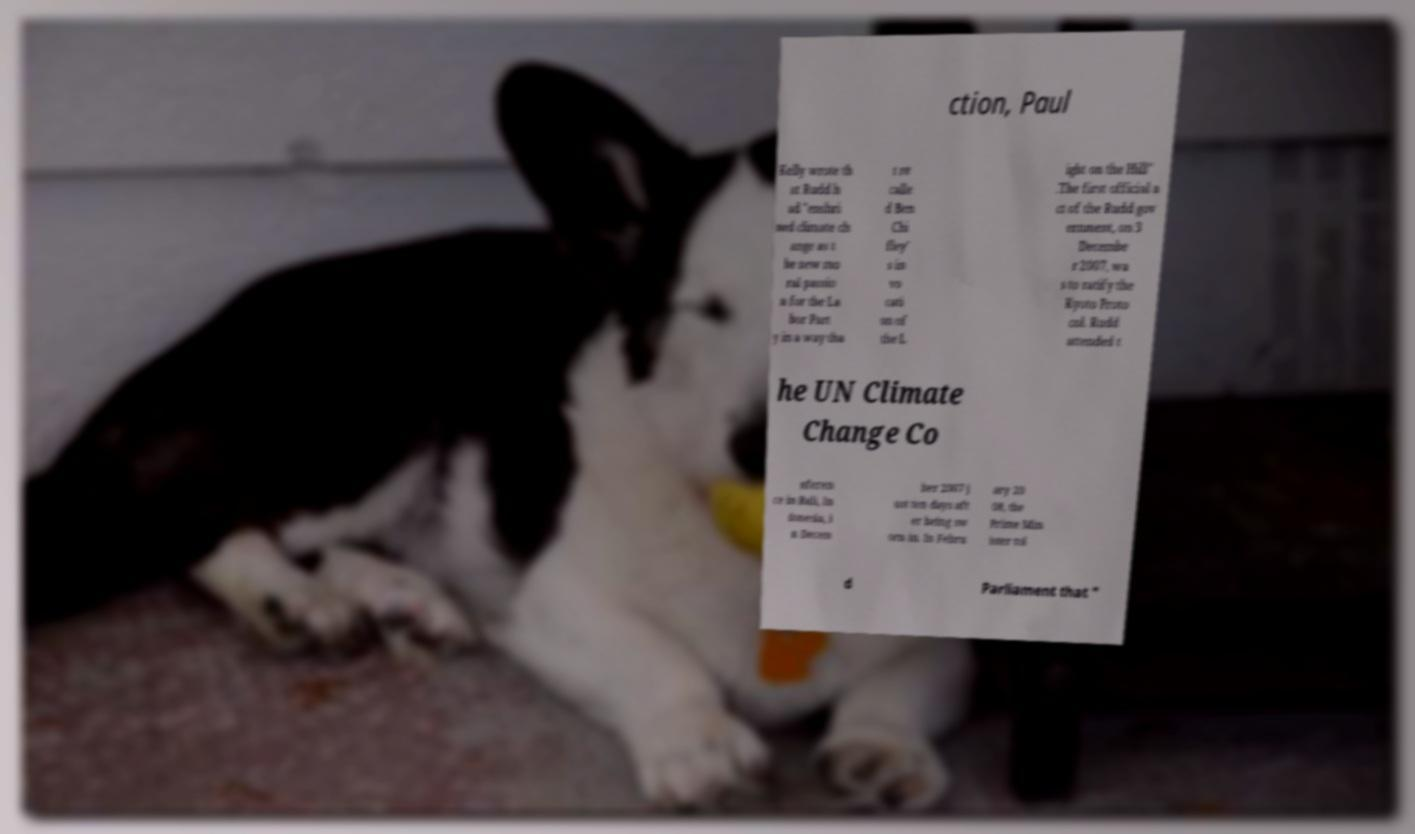What messages or text are displayed in this image? I need them in a readable, typed format. ction, Paul Kelly wrote th at Rudd h ad "enshri ned climate ch ange as t he new mo ral passio n for the La bor Part y in a way tha t re calle d Ben Chi fley' s in vo cati on of the L ight on the Hill" .The first official a ct of the Rudd gov ernment, on 3 Decembe r 2007, wa s to ratify the Kyoto Proto col. Rudd attended t he UN Climate Change Co nferen ce in Bali, In donesia, i n Decem ber 2007 j ust ten days aft er being sw orn in. In Febru ary 20 08, the Prime Min ister tol d Parliament that " 